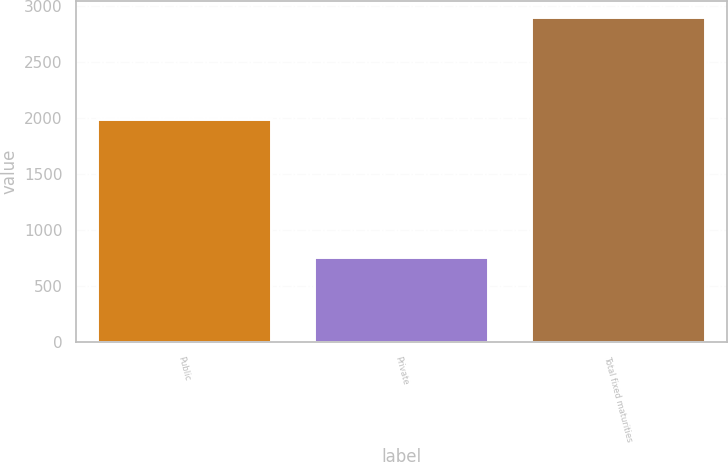Convert chart. <chart><loc_0><loc_0><loc_500><loc_500><bar_chart><fcel>Public<fcel>Private<fcel>Total fixed maturities<nl><fcel>1989.8<fcel>757.4<fcel>2907.6<nl></chart> 